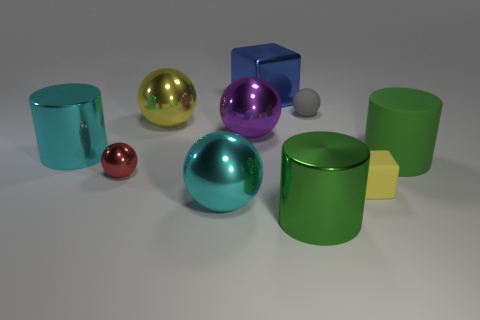Subtract 3 spheres. How many spheres are left? 2 Subtract all red balls. How many balls are left? 4 Subtract all red spheres. How many spheres are left? 4 Subtract all blue balls. Subtract all gray cubes. How many balls are left? 5 Subtract all blocks. How many objects are left? 8 Add 5 small green rubber cylinders. How many small green rubber cylinders exist? 5 Subtract 0 purple blocks. How many objects are left? 10 Subtract all large metallic things. Subtract all red matte cubes. How many objects are left? 4 Add 5 large blue cubes. How many large blue cubes are left? 6 